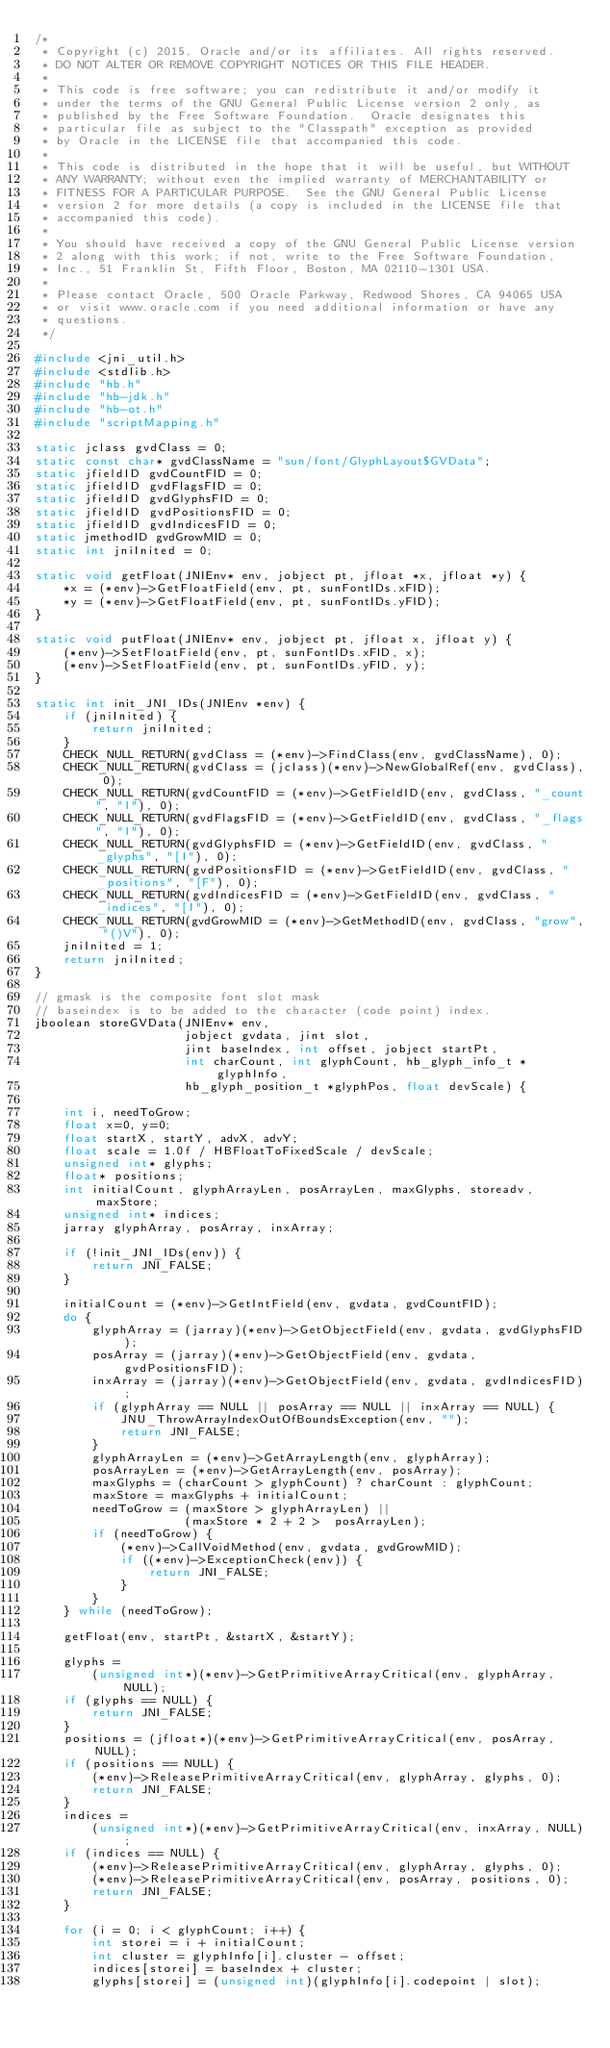Convert code to text. <code><loc_0><loc_0><loc_500><loc_500><_C_>/*
 * Copyright (c) 2015, Oracle and/or its affiliates. All rights reserved.
 * DO NOT ALTER OR REMOVE COPYRIGHT NOTICES OR THIS FILE HEADER.
 *
 * This code is free software; you can redistribute it and/or modify it
 * under the terms of the GNU General Public License version 2 only, as
 * published by the Free Software Foundation.  Oracle designates this
 * particular file as subject to the "Classpath" exception as provided
 * by Oracle in the LICENSE file that accompanied this code.
 *
 * This code is distributed in the hope that it will be useful, but WITHOUT
 * ANY WARRANTY; without even the implied warranty of MERCHANTABILITY or
 * FITNESS FOR A PARTICULAR PURPOSE.  See the GNU General Public License
 * version 2 for more details (a copy is included in the LICENSE file that
 * accompanied this code).
 *
 * You should have received a copy of the GNU General Public License version
 * 2 along with this work; if not, write to the Free Software Foundation,
 * Inc., 51 Franklin St, Fifth Floor, Boston, MA 02110-1301 USA.
 *
 * Please contact Oracle, 500 Oracle Parkway, Redwood Shores, CA 94065 USA
 * or visit www.oracle.com if you need additional information or have any
 * questions.
 */

#include <jni_util.h>
#include <stdlib.h>
#include "hb.h"
#include "hb-jdk.h"
#include "hb-ot.h"
#include "scriptMapping.h"

static jclass gvdClass = 0;
static const char* gvdClassName = "sun/font/GlyphLayout$GVData";
static jfieldID gvdCountFID = 0;
static jfieldID gvdFlagsFID = 0;
static jfieldID gvdGlyphsFID = 0;
static jfieldID gvdPositionsFID = 0;
static jfieldID gvdIndicesFID = 0;
static jmethodID gvdGrowMID = 0;
static int jniInited = 0;

static void getFloat(JNIEnv* env, jobject pt, jfloat *x, jfloat *y) {
    *x = (*env)->GetFloatField(env, pt, sunFontIDs.xFID);
    *y = (*env)->GetFloatField(env, pt, sunFontIDs.yFID);
}

static void putFloat(JNIEnv* env, jobject pt, jfloat x, jfloat y) {
    (*env)->SetFloatField(env, pt, sunFontIDs.xFID, x);
    (*env)->SetFloatField(env, pt, sunFontIDs.yFID, y);
}

static int init_JNI_IDs(JNIEnv *env) {
    if (jniInited) {
        return jniInited;
    }
    CHECK_NULL_RETURN(gvdClass = (*env)->FindClass(env, gvdClassName), 0);
    CHECK_NULL_RETURN(gvdClass = (jclass)(*env)->NewGlobalRef(env, gvdClass), 0);
    CHECK_NULL_RETURN(gvdCountFID = (*env)->GetFieldID(env, gvdClass, "_count", "I"), 0);
    CHECK_NULL_RETURN(gvdFlagsFID = (*env)->GetFieldID(env, gvdClass, "_flags", "I"), 0);
    CHECK_NULL_RETURN(gvdGlyphsFID = (*env)->GetFieldID(env, gvdClass, "_glyphs", "[I"), 0);
    CHECK_NULL_RETURN(gvdPositionsFID = (*env)->GetFieldID(env, gvdClass, "_positions", "[F"), 0);
    CHECK_NULL_RETURN(gvdIndicesFID = (*env)->GetFieldID(env, gvdClass, "_indices", "[I"), 0);
    CHECK_NULL_RETURN(gvdGrowMID = (*env)->GetMethodID(env, gvdClass, "grow", "()V"), 0);
    jniInited = 1;
    return jniInited;
}

// gmask is the composite font slot mask
// baseindex is to be added to the character (code point) index.
jboolean storeGVData(JNIEnv* env,
                     jobject gvdata, jint slot,
                     jint baseIndex, int offset, jobject startPt,
                     int charCount, int glyphCount, hb_glyph_info_t *glyphInfo,
                     hb_glyph_position_t *glyphPos, float devScale) {

    int i, needToGrow;
    float x=0, y=0;
    float startX, startY, advX, advY;
    float scale = 1.0f / HBFloatToFixedScale / devScale;
    unsigned int* glyphs;
    float* positions;
    int initialCount, glyphArrayLen, posArrayLen, maxGlyphs, storeadv, maxStore;
    unsigned int* indices;
    jarray glyphArray, posArray, inxArray;

    if (!init_JNI_IDs(env)) {
        return JNI_FALSE;
    }

    initialCount = (*env)->GetIntField(env, gvdata, gvdCountFID);
    do {
        glyphArray = (jarray)(*env)->GetObjectField(env, gvdata, gvdGlyphsFID);
        posArray = (jarray)(*env)->GetObjectField(env, gvdata, gvdPositionsFID);
        inxArray = (jarray)(*env)->GetObjectField(env, gvdata, gvdIndicesFID);
        if (glyphArray == NULL || posArray == NULL || inxArray == NULL) {
            JNU_ThrowArrayIndexOutOfBoundsException(env, "");
            return JNI_FALSE;
        }
        glyphArrayLen = (*env)->GetArrayLength(env, glyphArray);
        posArrayLen = (*env)->GetArrayLength(env, posArray);
        maxGlyphs = (charCount > glyphCount) ? charCount : glyphCount;
        maxStore = maxGlyphs + initialCount;
        needToGrow = (maxStore > glyphArrayLen) ||
                     (maxStore * 2 + 2 >  posArrayLen);
        if (needToGrow) {
            (*env)->CallVoidMethod(env, gvdata, gvdGrowMID);
            if ((*env)->ExceptionCheck(env)) {
                return JNI_FALSE;
            }
        }
    } while (needToGrow);

    getFloat(env, startPt, &startX, &startY);

    glyphs =
        (unsigned int*)(*env)->GetPrimitiveArrayCritical(env, glyphArray, NULL);
    if (glyphs == NULL) {
        return JNI_FALSE;
    }
    positions = (jfloat*)(*env)->GetPrimitiveArrayCritical(env, posArray, NULL);
    if (positions == NULL) {
        (*env)->ReleasePrimitiveArrayCritical(env, glyphArray, glyphs, 0);
        return JNI_FALSE;
    }
    indices =
        (unsigned int*)(*env)->GetPrimitiveArrayCritical(env, inxArray, NULL);
    if (indices == NULL) {
        (*env)->ReleasePrimitiveArrayCritical(env, glyphArray, glyphs, 0);
        (*env)->ReleasePrimitiveArrayCritical(env, posArray, positions, 0);
        return JNI_FALSE;
    }

    for (i = 0; i < glyphCount; i++) {
        int storei = i + initialCount;
        int cluster = glyphInfo[i].cluster - offset;
        indices[storei] = baseIndex + cluster;
        glyphs[storei] = (unsigned int)(glyphInfo[i].codepoint | slot);</code> 